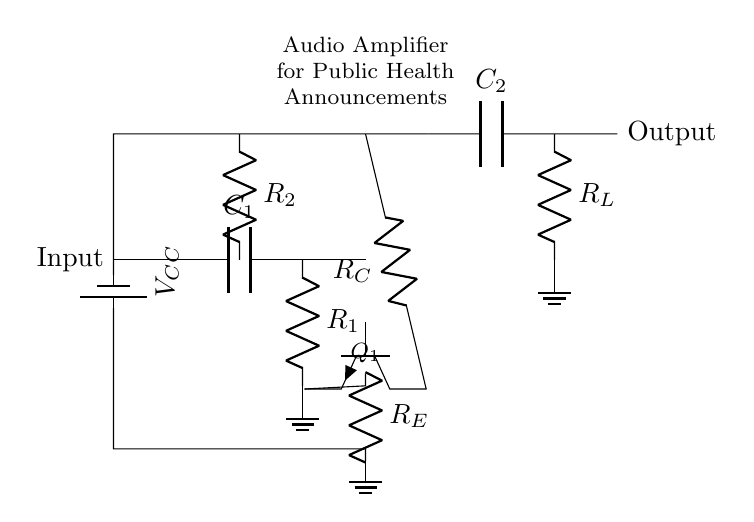What is the type of transistor used in the circuit? The circuit uses an NPN transistor as indicated by the label on the component. The symbol is standard for NPN transistors, which typically have one pin for the collector, one for the base, and one for the emitter.
Answer: NPN What does the capacitor C1 do in the circuit? Capacitor C1 serves to couple AC signals from the input while blocking any DC offset. In audio amplifiers, this is crucial to ensure that only the desired audio frequencies are amplified and not the DC component.
Answer: AC coupling What is the role of resistor R2 in the amplifier circuit? Resistor R2 is used for biasing the transistor. By providing the correct biasing voltage, it helps the transistor operate in the active region, which is necessary for audio amplification. This resistor affects the input impedance and stability of the amplifier.
Answer: Biasing What is the output load resistor represented in the circuit? The output load resistor in the circuit is denoted as R_L, which is responsible for the load that the amplifier will drive. It is connected in parallel with the output capacitor C2, affecting the overall impedance seen by the amplifier.
Answer: R_L Which component filters high-frequency noise in the output stage? Capacitor C2 is responsible for smoothing and filtering out high-frequency noise in the output signal. It allows desired audio frequencies to pass while blocking unwanted high-frequency components, ensuring a cleaner audio signal is transmitted.
Answer: C2 